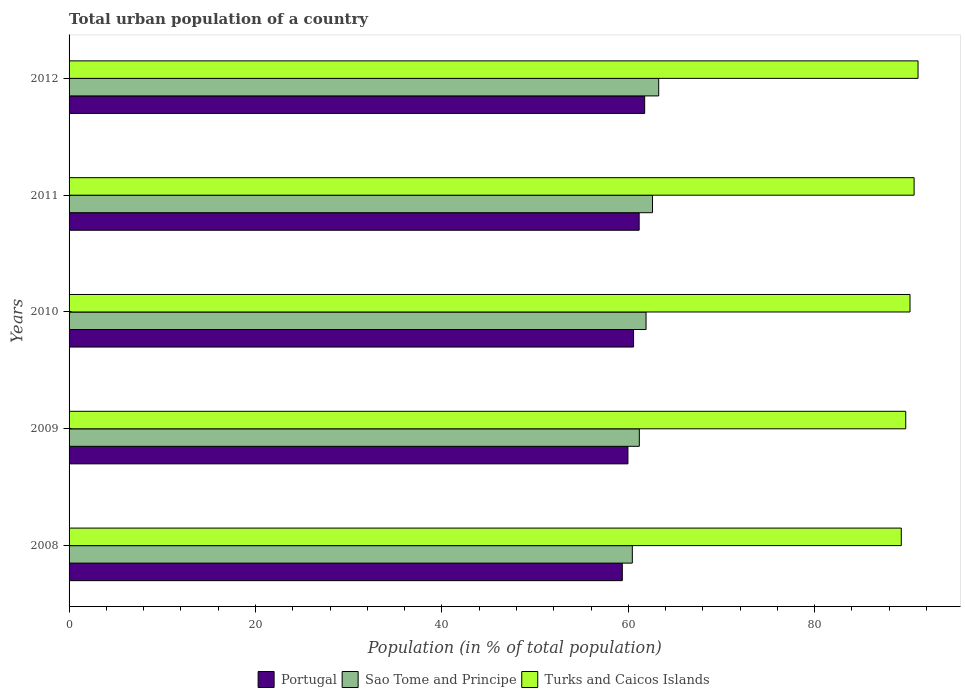How many groups of bars are there?
Keep it short and to the point. 5. Are the number of bars per tick equal to the number of legend labels?
Your answer should be compact. Yes. Are the number of bars on each tick of the Y-axis equal?
Provide a short and direct response. Yes. How many bars are there on the 3rd tick from the top?
Give a very brief answer. 3. How many bars are there on the 4th tick from the bottom?
Give a very brief answer. 3. What is the label of the 5th group of bars from the top?
Offer a terse response. 2008. In how many cases, is the number of bars for a given year not equal to the number of legend labels?
Provide a short and direct response. 0. What is the urban population in Portugal in 2012?
Your response must be concise. 61.76. Across all years, what is the maximum urban population in Portugal?
Offer a terse response. 61.76. Across all years, what is the minimum urban population in Turks and Caicos Islands?
Your response must be concise. 89.29. In which year was the urban population in Sao Tome and Principe maximum?
Offer a terse response. 2012. What is the total urban population in Portugal in the graph?
Your answer should be compact. 302.81. What is the difference between the urban population in Portugal in 2008 and that in 2011?
Offer a terse response. -1.81. What is the difference between the urban population in Portugal in 2009 and the urban population in Turks and Caicos Islands in 2008?
Give a very brief answer. -29.33. What is the average urban population in Turks and Caicos Islands per year?
Your answer should be compact. 90.21. In the year 2009, what is the difference between the urban population in Sao Tome and Principe and urban population in Portugal?
Ensure brevity in your answer.  1.22. What is the ratio of the urban population in Sao Tome and Principe in 2008 to that in 2012?
Ensure brevity in your answer.  0.96. Is the urban population in Portugal in 2008 less than that in 2012?
Keep it short and to the point. Yes. Is the difference between the urban population in Sao Tome and Principe in 2009 and 2011 greater than the difference between the urban population in Portugal in 2009 and 2011?
Provide a succinct answer. No. What is the difference between the highest and the second highest urban population in Turks and Caicos Islands?
Keep it short and to the point. 0.42. What is the difference between the highest and the lowest urban population in Sao Tome and Principe?
Offer a very short reply. 2.83. Is the sum of the urban population in Turks and Caicos Islands in 2010 and 2011 greater than the maximum urban population in Sao Tome and Principe across all years?
Offer a very short reply. Yes. What does the 3rd bar from the top in 2008 represents?
Your answer should be very brief. Portugal. What does the 2nd bar from the bottom in 2008 represents?
Offer a terse response. Sao Tome and Principe. How many bars are there?
Make the answer very short. 15. How many years are there in the graph?
Ensure brevity in your answer.  5. Are the values on the major ticks of X-axis written in scientific E-notation?
Offer a terse response. No. Does the graph contain grids?
Provide a short and direct response. No. How are the legend labels stacked?
Your response must be concise. Horizontal. What is the title of the graph?
Keep it short and to the point. Total urban population of a country. Does "St. Martin (French part)" appear as one of the legend labels in the graph?
Provide a short and direct response. No. What is the label or title of the X-axis?
Offer a terse response. Population (in % of total population). What is the Population (in % of total population) of Portugal in 2008?
Provide a succinct answer. 59.36. What is the Population (in % of total population) of Sao Tome and Principe in 2008?
Your answer should be very brief. 60.43. What is the Population (in % of total population) of Turks and Caicos Islands in 2008?
Offer a terse response. 89.29. What is the Population (in % of total population) in Portugal in 2009?
Offer a terse response. 59.96. What is the Population (in % of total population) in Sao Tome and Principe in 2009?
Keep it short and to the point. 61.19. What is the Population (in % of total population) of Turks and Caicos Islands in 2009?
Provide a succinct answer. 89.77. What is the Population (in % of total population) of Portugal in 2010?
Your answer should be compact. 60.57. What is the Population (in % of total population) in Sao Tome and Principe in 2010?
Offer a very short reply. 61.91. What is the Population (in % of total population) of Turks and Caicos Islands in 2010?
Give a very brief answer. 90.23. What is the Population (in % of total population) of Portugal in 2011?
Provide a short and direct response. 61.17. What is the Population (in % of total population) in Sao Tome and Principe in 2011?
Your answer should be compact. 62.6. What is the Population (in % of total population) in Turks and Caicos Islands in 2011?
Offer a very short reply. 90.67. What is the Population (in % of total population) of Portugal in 2012?
Ensure brevity in your answer.  61.76. What is the Population (in % of total population) of Sao Tome and Principe in 2012?
Your answer should be compact. 63.27. What is the Population (in % of total population) of Turks and Caicos Islands in 2012?
Your answer should be compact. 91.09. Across all years, what is the maximum Population (in % of total population) in Portugal?
Your answer should be very brief. 61.76. Across all years, what is the maximum Population (in % of total population) of Sao Tome and Principe?
Provide a succinct answer. 63.27. Across all years, what is the maximum Population (in % of total population) of Turks and Caicos Islands?
Provide a succinct answer. 91.09. Across all years, what is the minimum Population (in % of total population) of Portugal?
Keep it short and to the point. 59.36. Across all years, what is the minimum Population (in % of total population) in Sao Tome and Principe?
Ensure brevity in your answer.  60.43. Across all years, what is the minimum Population (in % of total population) in Turks and Caicos Islands?
Your answer should be compact. 89.29. What is the total Population (in % of total population) in Portugal in the graph?
Offer a very short reply. 302.81. What is the total Population (in % of total population) in Sao Tome and Principe in the graph?
Give a very brief answer. 309.39. What is the total Population (in % of total population) in Turks and Caicos Islands in the graph?
Give a very brief answer. 451.05. What is the difference between the Population (in % of total population) of Portugal in 2008 and that in 2009?
Provide a short and direct response. -0.6. What is the difference between the Population (in % of total population) of Sao Tome and Principe in 2008 and that in 2009?
Offer a very short reply. -0.75. What is the difference between the Population (in % of total population) in Turks and Caicos Islands in 2008 and that in 2009?
Your answer should be compact. -0.48. What is the difference between the Population (in % of total population) in Portugal in 2008 and that in 2010?
Provide a succinct answer. -1.21. What is the difference between the Population (in % of total population) in Sao Tome and Principe in 2008 and that in 2010?
Your answer should be compact. -1.47. What is the difference between the Population (in % of total population) in Turks and Caicos Islands in 2008 and that in 2010?
Your answer should be compact. -0.93. What is the difference between the Population (in % of total population) of Portugal in 2008 and that in 2011?
Give a very brief answer. -1.81. What is the difference between the Population (in % of total population) of Sao Tome and Principe in 2008 and that in 2011?
Provide a short and direct response. -2.17. What is the difference between the Population (in % of total population) of Turks and Caicos Islands in 2008 and that in 2011?
Provide a short and direct response. -1.37. What is the difference between the Population (in % of total population) in Portugal in 2008 and that in 2012?
Offer a very short reply. -2.4. What is the difference between the Population (in % of total population) in Sao Tome and Principe in 2008 and that in 2012?
Your response must be concise. -2.83. What is the difference between the Population (in % of total population) in Turks and Caicos Islands in 2008 and that in 2012?
Keep it short and to the point. -1.8. What is the difference between the Population (in % of total population) of Portugal in 2009 and that in 2010?
Offer a very short reply. -0.6. What is the difference between the Population (in % of total population) in Sao Tome and Principe in 2009 and that in 2010?
Your response must be concise. -0.72. What is the difference between the Population (in % of total population) in Turks and Caicos Islands in 2009 and that in 2010?
Offer a terse response. -0.46. What is the difference between the Population (in % of total population) in Portugal in 2009 and that in 2011?
Your response must be concise. -1.2. What is the difference between the Population (in % of total population) in Sao Tome and Principe in 2009 and that in 2011?
Provide a short and direct response. -1.42. What is the difference between the Population (in % of total population) in Turks and Caicos Islands in 2009 and that in 2011?
Make the answer very short. -0.9. What is the difference between the Population (in % of total population) in Portugal in 2009 and that in 2012?
Your answer should be very brief. -1.79. What is the difference between the Population (in % of total population) of Sao Tome and Principe in 2009 and that in 2012?
Your answer should be compact. -2.08. What is the difference between the Population (in % of total population) in Turks and Caicos Islands in 2009 and that in 2012?
Your answer should be compact. -1.32. What is the difference between the Population (in % of total population) of Sao Tome and Principe in 2010 and that in 2011?
Ensure brevity in your answer.  -0.69. What is the difference between the Population (in % of total population) of Turks and Caicos Islands in 2010 and that in 2011?
Offer a very short reply. -0.44. What is the difference between the Population (in % of total population) in Portugal in 2010 and that in 2012?
Provide a short and direct response. -1.19. What is the difference between the Population (in % of total population) in Sao Tome and Principe in 2010 and that in 2012?
Offer a terse response. -1.36. What is the difference between the Population (in % of total population) of Turks and Caicos Islands in 2010 and that in 2012?
Offer a very short reply. -0.86. What is the difference between the Population (in % of total population) in Portugal in 2011 and that in 2012?
Provide a short and direct response. -0.59. What is the difference between the Population (in % of total population) of Sao Tome and Principe in 2011 and that in 2012?
Offer a terse response. -0.67. What is the difference between the Population (in % of total population) of Turks and Caicos Islands in 2011 and that in 2012?
Make the answer very short. -0.42. What is the difference between the Population (in % of total population) of Portugal in 2008 and the Population (in % of total population) of Sao Tome and Principe in 2009?
Keep it short and to the point. -1.83. What is the difference between the Population (in % of total population) in Portugal in 2008 and the Population (in % of total population) in Turks and Caicos Islands in 2009?
Your answer should be compact. -30.41. What is the difference between the Population (in % of total population) of Sao Tome and Principe in 2008 and the Population (in % of total population) of Turks and Caicos Islands in 2009?
Give a very brief answer. -29.34. What is the difference between the Population (in % of total population) of Portugal in 2008 and the Population (in % of total population) of Sao Tome and Principe in 2010?
Provide a short and direct response. -2.55. What is the difference between the Population (in % of total population) of Portugal in 2008 and the Population (in % of total population) of Turks and Caicos Islands in 2010?
Provide a short and direct response. -30.87. What is the difference between the Population (in % of total population) of Sao Tome and Principe in 2008 and the Population (in % of total population) of Turks and Caicos Islands in 2010?
Keep it short and to the point. -29.79. What is the difference between the Population (in % of total population) of Portugal in 2008 and the Population (in % of total population) of Sao Tome and Principe in 2011?
Give a very brief answer. -3.24. What is the difference between the Population (in % of total population) in Portugal in 2008 and the Population (in % of total population) in Turks and Caicos Islands in 2011?
Your answer should be very brief. -31.31. What is the difference between the Population (in % of total population) of Sao Tome and Principe in 2008 and the Population (in % of total population) of Turks and Caicos Islands in 2011?
Make the answer very short. -30.23. What is the difference between the Population (in % of total population) of Portugal in 2008 and the Population (in % of total population) of Sao Tome and Principe in 2012?
Offer a very short reply. -3.91. What is the difference between the Population (in % of total population) in Portugal in 2008 and the Population (in % of total population) in Turks and Caicos Islands in 2012?
Offer a very short reply. -31.73. What is the difference between the Population (in % of total population) in Sao Tome and Principe in 2008 and the Population (in % of total population) in Turks and Caicos Islands in 2012?
Ensure brevity in your answer.  -30.66. What is the difference between the Population (in % of total population) of Portugal in 2009 and the Population (in % of total population) of Sao Tome and Principe in 2010?
Offer a terse response. -1.94. What is the difference between the Population (in % of total population) of Portugal in 2009 and the Population (in % of total population) of Turks and Caicos Islands in 2010?
Your response must be concise. -30.26. What is the difference between the Population (in % of total population) of Sao Tome and Principe in 2009 and the Population (in % of total population) of Turks and Caicos Islands in 2010?
Ensure brevity in your answer.  -29.04. What is the difference between the Population (in % of total population) in Portugal in 2009 and the Population (in % of total population) in Sao Tome and Principe in 2011?
Ensure brevity in your answer.  -2.64. What is the difference between the Population (in % of total population) of Portugal in 2009 and the Population (in % of total population) of Turks and Caicos Islands in 2011?
Give a very brief answer. -30.7. What is the difference between the Population (in % of total population) in Sao Tome and Principe in 2009 and the Population (in % of total population) in Turks and Caicos Islands in 2011?
Offer a terse response. -29.48. What is the difference between the Population (in % of total population) of Portugal in 2009 and the Population (in % of total population) of Sao Tome and Principe in 2012?
Offer a very short reply. -3.3. What is the difference between the Population (in % of total population) in Portugal in 2009 and the Population (in % of total population) in Turks and Caicos Islands in 2012?
Your answer should be compact. -31.13. What is the difference between the Population (in % of total population) of Sao Tome and Principe in 2009 and the Population (in % of total population) of Turks and Caicos Islands in 2012?
Your answer should be compact. -29.91. What is the difference between the Population (in % of total population) of Portugal in 2010 and the Population (in % of total population) of Sao Tome and Principe in 2011?
Provide a succinct answer. -2.03. What is the difference between the Population (in % of total population) of Portugal in 2010 and the Population (in % of total population) of Turks and Caicos Islands in 2011?
Offer a terse response. -30.1. What is the difference between the Population (in % of total population) in Sao Tome and Principe in 2010 and the Population (in % of total population) in Turks and Caicos Islands in 2011?
Provide a short and direct response. -28.76. What is the difference between the Population (in % of total population) in Portugal in 2010 and the Population (in % of total population) in Sao Tome and Principe in 2012?
Keep it short and to the point. -2.7. What is the difference between the Population (in % of total population) in Portugal in 2010 and the Population (in % of total population) in Turks and Caicos Islands in 2012?
Offer a terse response. -30.52. What is the difference between the Population (in % of total population) in Sao Tome and Principe in 2010 and the Population (in % of total population) in Turks and Caicos Islands in 2012?
Offer a very short reply. -29.18. What is the difference between the Population (in % of total population) of Portugal in 2011 and the Population (in % of total population) of Sao Tome and Principe in 2012?
Offer a very short reply. -2.1. What is the difference between the Population (in % of total population) of Portugal in 2011 and the Population (in % of total population) of Turks and Caicos Islands in 2012?
Your answer should be compact. -29.92. What is the difference between the Population (in % of total population) in Sao Tome and Principe in 2011 and the Population (in % of total population) in Turks and Caicos Islands in 2012?
Offer a terse response. -28.49. What is the average Population (in % of total population) in Portugal per year?
Your answer should be very brief. 60.56. What is the average Population (in % of total population) in Sao Tome and Principe per year?
Provide a short and direct response. 61.88. What is the average Population (in % of total population) of Turks and Caicos Islands per year?
Your answer should be very brief. 90.21. In the year 2008, what is the difference between the Population (in % of total population) of Portugal and Population (in % of total population) of Sao Tome and Principe?
Offer a very short reply. -1.07. In the year 2008, what is the difference between the Population (in % of total population) in Portugal and Population (in % of total population) in Turks and Caicos Islands?
Keep it short and to the point. -29.93. In the year 2008, what is the difference between the Population (in % of total population) in Sao Tome and Principe and Population (in % of total population) in Turks and Caicos Islands?
Keep it short and to the point. -28.86. In the year 2009, what is the difference between the Population (in % of total population) in Portugal and Population (in % of total population) in Sao Tome and Principe?
Provide a succinct answer. -1.22. In the year 2009, what is the difference between the Population (in % of total population) of Portugal and Population (in % of total population) of Turks and Caicos Islands?
Your response must be concise. -29.81. In the year 2009, what is the difference between the Population (in % of total population) of Sao Tome and Principe and Population (in % of total population) of Turks and Caicos Islands?
Ensure brevity in your answer.  -28.59. In the year 2010, what is the difference between the Population (in % of total population) of Portugal and Population (in % of total population) of Sao Tome and Principe?
Offer a terse response. -1.34. In the year 2010, what is the difference between the Population (in % of total population) of Portugal and Population (in % of total population) of Turks and Caicos Islands?
Provide a succinct answer. -29.66. In the year 2010, what is the difference between the Population (in % of total population) in Sao Tome and Principe and Population (in % of total population) in Turks and Caicos Islands?
Make the answer very short. -28.32. In the year 2011, what is the difference between the Population (in % of total population) in Portugal and Population (in % of total population) in Sao Tome and Principe?
Give a very brief answer. -1.43. In the year 2011, what is the difference between the Population (in % of total population) in Portugal and Population (in % of total population) in Turks and Caicos Islands?
Keep it short and to the point. -29.5. In the year 2011, what is the difference between the Population (in % of total population) in Sao Tome and Principe and Population (in % of total population) in Turks and Caicos Islands?
Make the answer very short. -28.07. In the year 2012, what is the difference between the Population (in % of total population) of Portugal and Population (in % of total population) of Sao Tome and Principe?
Your response must be concise. -1.51. In the year 2012, what is the difference between the Population (in % of total population) of Portugal and Population (in % of total population) of Turks and Caicos Islands?
Make the answer very short. -29.33. In the year 2012, what is the difference between the Population (in % of total population) of Sao Tome and Principe and Population (in % of total population) of Turks and Caicos Islands?
Give a very brief answer. -27.82. What is the ratio of the Population (in % of total population) of Portugal in 2008 to that in 2010?
Your answer should be compact. 0.98. What is the ratio of the Population (in % of total population) of Sao Tome and Principe in 2008 to that in 2010?
Ensure brevity in your answer.  0.98. What is the ratio of the Population (in % of total population) of Portugal in 2008 to that in 2011?
Your response must be concise. 0.97. What is the ratio of the Population (in % of total population) of Sao Tome and Principe in 2008 to that in 2011?
Offer a terse response. 0.97. What is the ratio of the Population (in % of total population) in Portugal in 2008 to that in 2012?
Provide a short and direct response. 0.96. What is the ratio of the Population (in % of total population) of Sao Tome and Principe in 2008 to that in 2012?
Provide a succinct answer. 0.96. What is the ratio of the Population (in % of total population) of Turks and Caicos Islands in 2008 to that in 2012?
Your answer should be compact. 0.98. What is the ratio of the Population (in % of total population) of Sao Tome and Principe in 2009 to that in 2010?
Provide a short and direct response. 0.99. What is the ratio of the Population (in % of total population) in Turks and Caicos Islands in 2009 to that in 2010?
Make the answer very short. 0.99. What is the ratio of the Population (in % of total population) in Portugal in 2009 to that in 2011?
Provide a succinct answer. 0.98. What is the ratio of the Population (in % of total population) of Sao Tome and Principe in 2009 to that in 2011?
Provide a short and direct response. 0.98. What is the ratio of the Population (in % of total population) of Turks and Caicos Islands in 2009 to that in 2011?
Your answer should be very brief. 0.99. What is the ratio of the Population (in % of total population) in Portugal in 2009 to that in 2012?
Ensure brevity in your answer.  0.97. What is the ratio of the Population (in % of total population) of Sao Tome and Principe in 2009 to that in 2012?
Your answer should be compact. 0.97. What is the ratio of the Population (in % of total population) in Turks and Caicos Islands in 2009 to that in 2012?
Your answer should be compact. 0.99. What is the ratio of the Population (in % of total population) of Portugal in 2010 to that in 2011?
Offer a terse response. 0.99. What is the ratio of the Population (in % of total population) of Sao Tome and Principe in 2010 to that in 2011?
Your answer should be very brief. 0.99. What is the ratio of the Population (in % of total population) of Turks and Caicos Islands in 2010 to that in 2011?
Your response must be concise. 1. What is the ratio of the Population (in % of total population) of Portugal in 2010 to that in 2012?
Provide a succinct answer. 0.98. What is the ratio of the Population (in % of total population) of Sao Tome and Principe in 2010 to that in 2012?
Provide a short and direct response. 0.98. What is the ratio of the Population (in % of total population) of Sao Tome and Principe in 2011 to that in 2012?
Your answer should be compact. 0.99. What is the difference between the highest and the second highest Population (in % of total population) in Portugal?
Offer a very short reply. 0.59. What is the difference between the highest and the second highest Population (in % of total population) in Sao Tome and Principe?
Offer a very short reply. 0.67. What is the difference between the highest and the second highest Population (in % of total population) in Turks and Caicos Islands?
Ensure brevity in your answer.  0.42. What is the difference between the highest and the lowest Population (in % of total population) of Portugal?
Make the answer very short. 2.4. What is the difference between the highest and the lowest Population (in % of total population) in Sao Tome and Principe?
Keep it short and to the point. 2.83. What is the difference between the highest and the lowest Population (in % of total population) in Turks and Caicos Islands?
Provide a succinct answer. 1.8. 